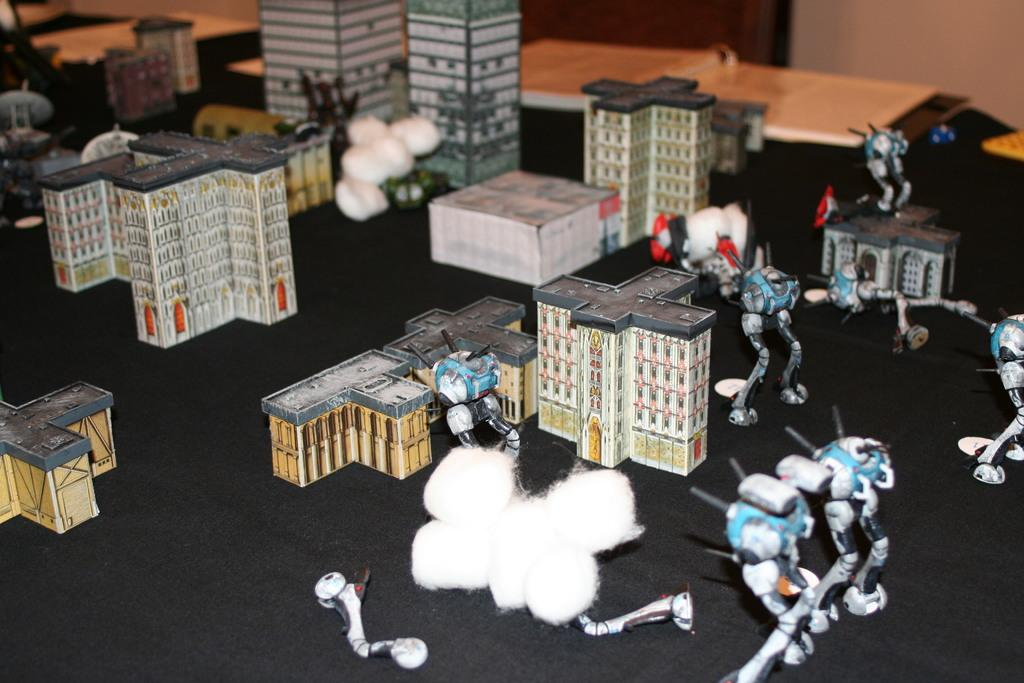What objects can be seen in the image? There are toys and buildings in the image. What structures are visible in the background? There is a wall and a door in the background of the image. Is there any indication of a floor or surface in the image? There might be a cloth at the bottom of the image, which could be a floor or surface. How many bridges can be seen in the image? There are no bridges present in the image. What type of answer is being given in the image? There is no indication of an answer being given in the image. 